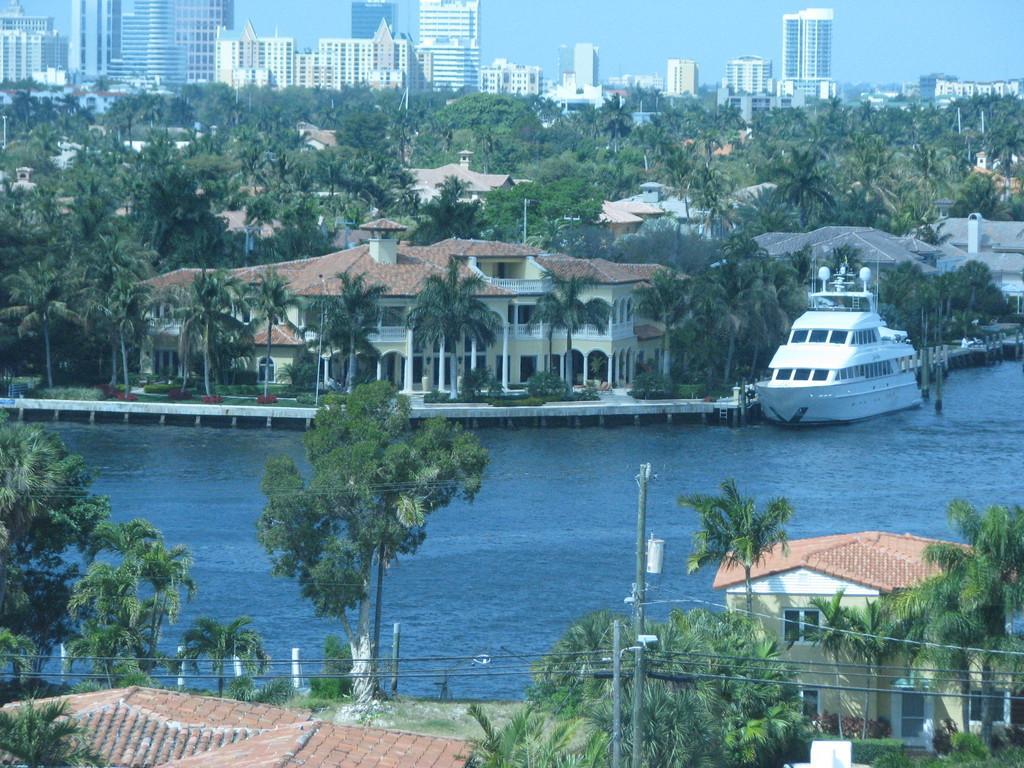Describe this image in one or two sentences. In this image, there is an outside view. There is a boat on the right side of the image floating on the water. There is a building and some trees in the middle of the image. There are some buildings at the top of the image. There are some other trees at the bottom of the image. 